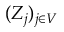Convert formula to latex. <formula><loc_0><loc_0><loc_500><loc_500>( Z _ { j } ) _ { j \in V }</formula> 